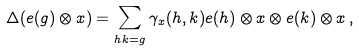Convert formula to latex. <formula><loc_0><loc_0><loc_500><loc_500>\Delta ( e ( g ) \otimes x ) = \sum _ { h k = g } \gamma _ { x } ( h , k ) e ( h ) \otimes x \otimes e ( k ) \otimes x \, ,</formula> 